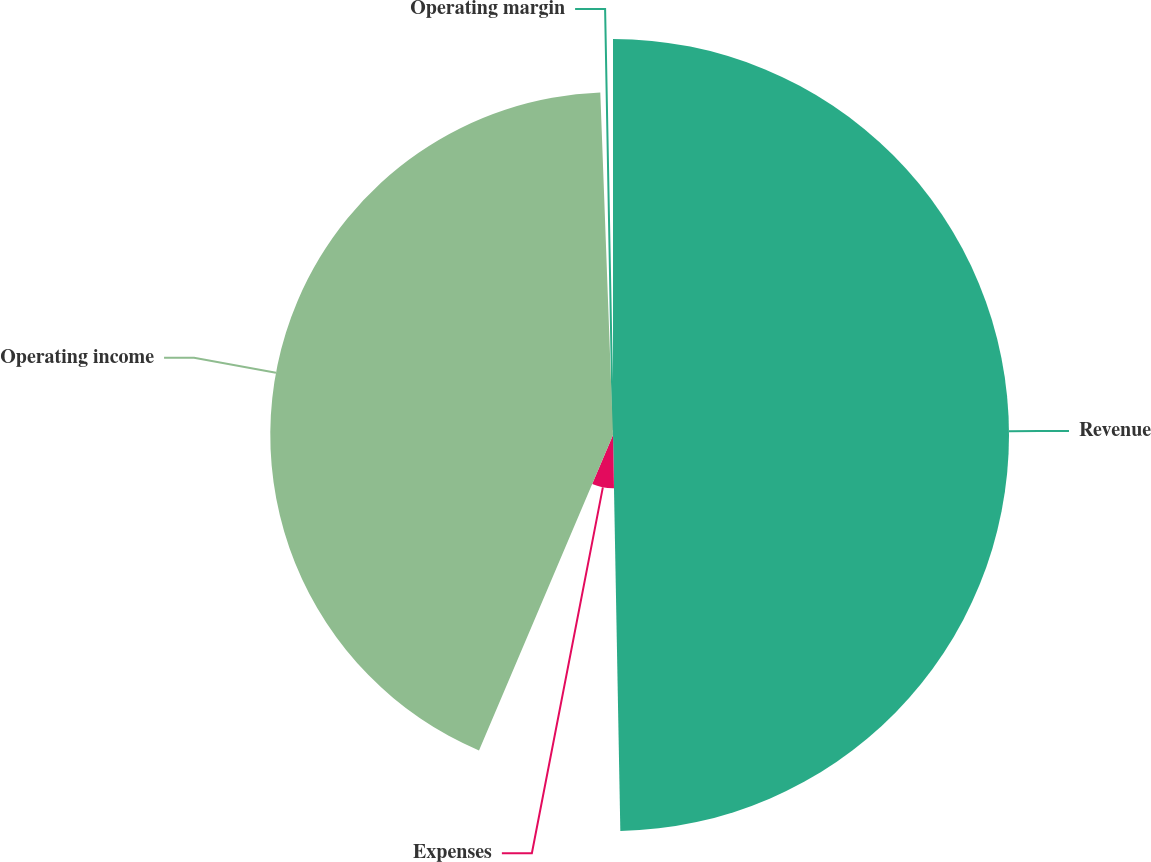Convert chart to OTSL. <chart><loc_0><loc_0><loc_500><loc_500><pie_chart><fcel>Revenue<fcel>Expenses<fcel>Operating income<fcel>Operating margin<nl><fcel>49.71%<fcel>6.69%<fcel>43.02%<fcel>0.59%<nl></chart> 